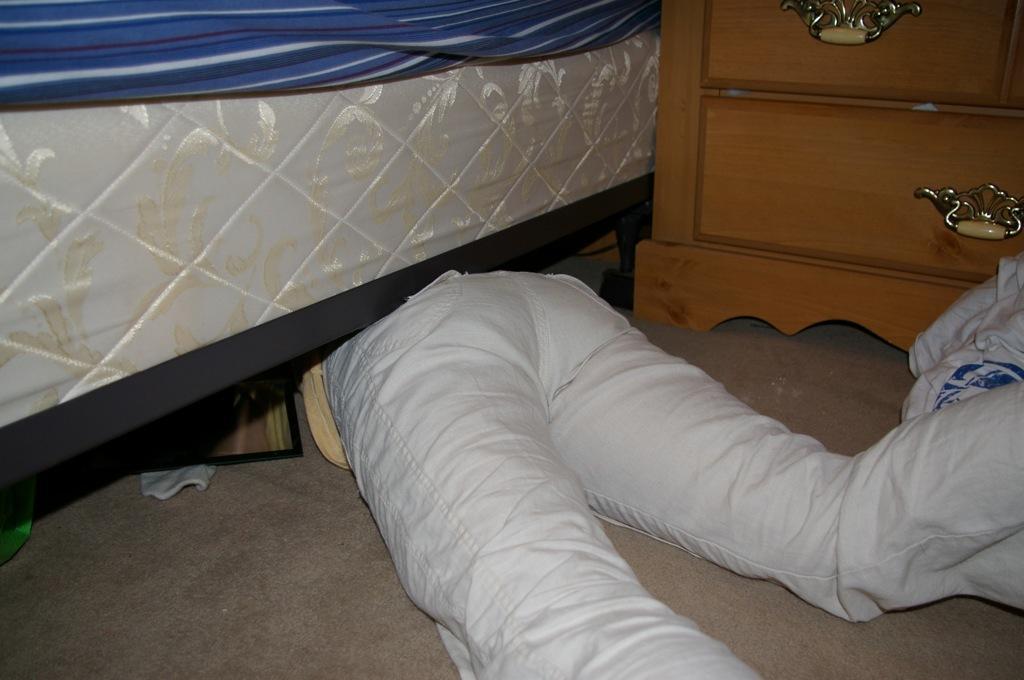Please provide a concise description of this image. This is the picture inside of the room. There is a person lying on the floor under the bed. At the back there is a table and there is a blue color bed sheet on the mattress. 